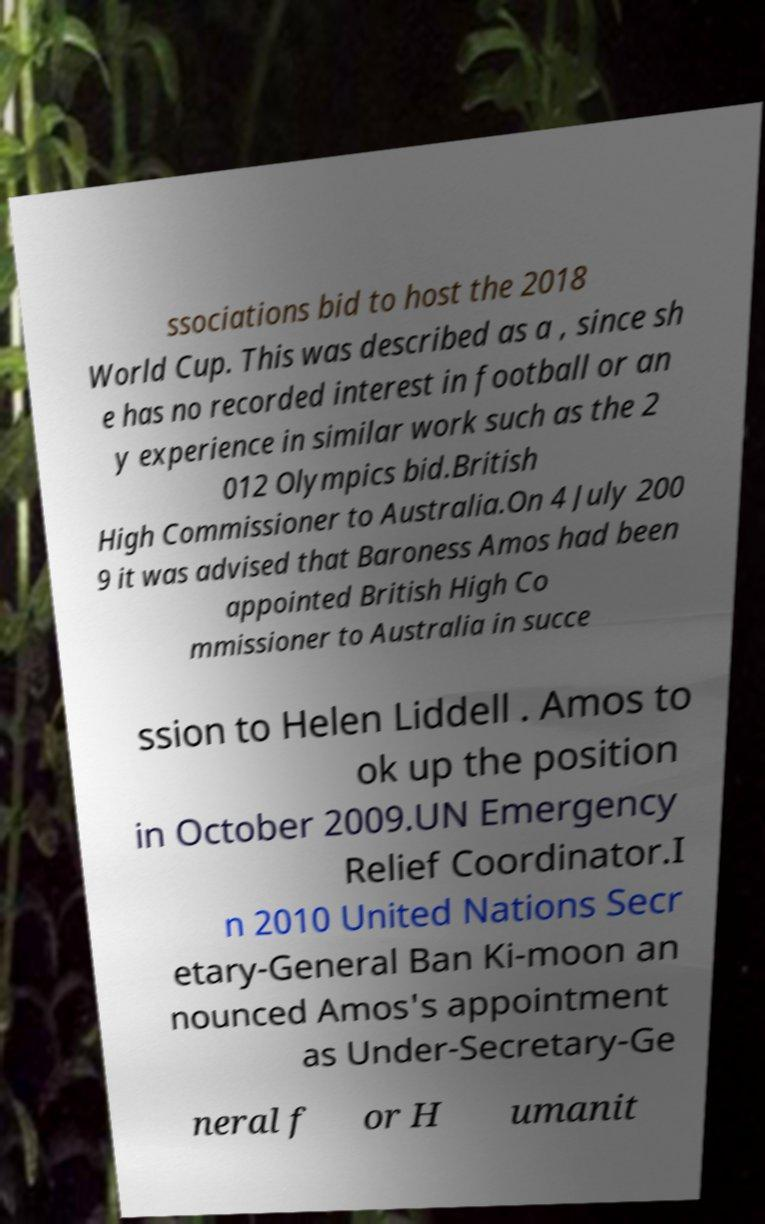I need the written content from this picture converted into text. Can you do that? ssociations bid to host the 2018 World Cup. This was described as a , since sh e has no recorded interest in football or an y experience in similar work such as the 2 012 Olympics bid.British High Commissioner to Australia.On 4 July 200 9 it was advised that Baroness Amos had been appointed British High Co mmissioner to Australia in succe ssion to Helen Liddell . Amos to ok up the position in October 2009.UN Emergency Relief Coordinator.I n 2010 United Nations Secr etary-General Ban Ki-moon an nounced Amos's appointment as Under-Secretary-Ge neral f or H umanit 